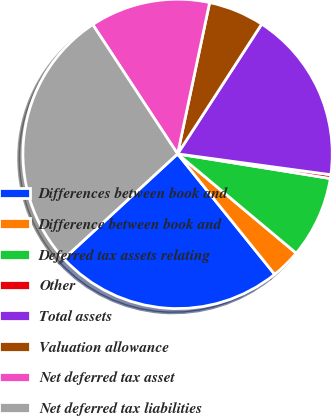<chart> <loc_0><loc_0><loc_500><loc_500><pie_chart><fcel>Differences between book and<fcel>Difference between book and<fcel>Deferred tax assets relating<fcel>Other<fcel>Total assets<fcel>Valuation allowance<fcel>Net deferred tax asset<fcel>Net deferred tax liabilities<nl><fcel>23.94%<fcel>3.11%<fcel>8.55%<fcel>0.39%<fcel>18.0%<fcel>5.83%<fcel>12.56%<fcel>27.61%<nl></chart> 